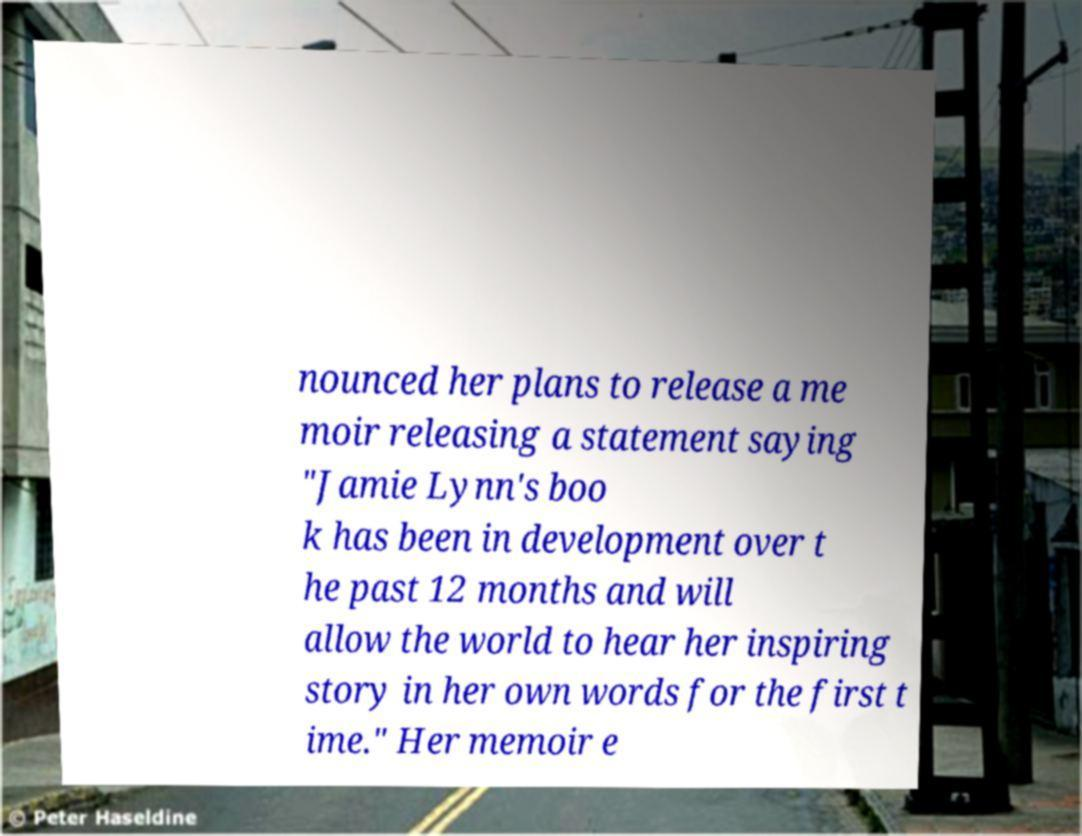What messages or text are displayed in this image? I need them in a readable, typed format. nounced her plans to release a me moir releasing a statement saying "Jamie Lynn's boo k has been in development over t he past 12 months and will allow the world to hear her inspiring story in her own words for the first t ime." Her memoir e 